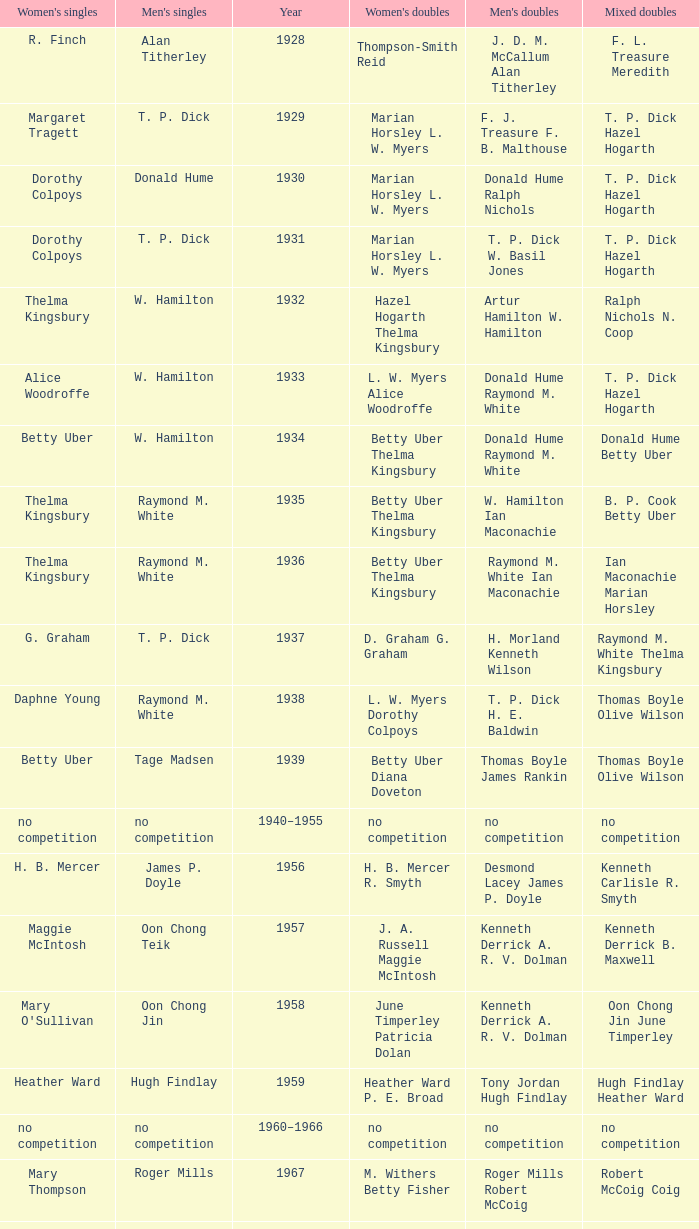Who won the Women's singles, in the year that Raymond M. White won the Men's singles and that W. Hamilton Ian Maconachie won the Men's doubles? Thelma Kingsbury. Parse the full table. {'header': ["Women's singles", "Men's singles", 'Year', "Women's doubles", "Men's doubles", 'Mixed doubles'], 'rows': [['R. Finch', 'Alan Titherley', '1928', 'Thompson-Smith Reid', 'J. D. M. McCallum Alan Titherley', 'F. L. Treasure Meredith'], ['Margaret Tragett', 'T. P. Dick', '1929', 'Marian Horsley L. W. Myers', 'F. J. Treasure F. B. Malthouse', 'T. P. Dick Hazel Hogarth'], ['Dorothy Colpoys', 'Donald Hume', '1930', 'Marian Horsley L. W. Myers', 'Donald Hume Ralph Nichols', 'T. P. Dick Hazel Hogarth'], ['Dorothy Colpoys', 'T. P. Dick', '1931', 'Marian Horsley L. W. Myers', 'T. P. Dick W. Basil Jones', 'T. P. Dick Hazel Hogarth'], ['Thelma Kingsbury', 'W. Hamilton', '1932', 'Hazel Hogarth Thelma Kingsbury', 'Artur Hamilton W. Hamilton', 'Ralph Nichols N. Coop'], ['Alice Woodroffe', 'W. Hamilton', '1933', 'L. W. Myers Alice Woodroffe', 'Donald Hume Raymond M. White', 'T. P. Dick Hazel Hogarth'], ['Betty Uber', 'W. Hamilton', '1934', 'Betty Uber Thelma Kingsbury', 'Donald Hume Raymond M. White', 'Donald Hume Betty Uber'], ['Thelma Kingsbury', 'Raymond M. White', '1935', 'Betty Uber Thelma Kingsbury', 'W. Hamilton Ian Maconachie', 'B. P. Cook Betty Uber'], ['Thelma Kingsbury', 'Raymond M. White', '1936', 'Betty Uber Thelma Kingsbury', 'Raymond M. White Ian Maconachie', 'Ian Maconachie Marian Horsley'], ['G. Graham', 'T. P. Dick', '1937', 'D. Graham G. Graham', 'H. Morland Kenneth Wilson', 'Raymond M. White Thelma Kingsbury'], ['Daphne Young', 'Raymond M. White', '1938', 'L. W. Myers Dorothy Colpoys', 'T. P. Dick H. E. Baldwin', 'Thomas Boyle Olive Wilson'], ['Betty Uber', 'Tage Madsen', '1939', 'Betty Uber Diana Doveton', 'Thomas Boyle James Rankin', 'Thomas Boyle Olive Wilson'], ['no competition', 'no competition', '1940–1955', 'no competition', 'no competition', 'no competition'], ['H. B. Mercer', 'James P. Doyle', '1956', 'H. B. Mercer R. Smyth', 'Desmond Lacey James P. Doyle', 'Kenneth Carlisle R. Smyth'], ['Maggie McIntosh', 'Oon Chong Teik', '1957', 'J. A. Russell Maggie McIntosh', 'Kenneth Derrick A. R. V. Dolman', 'Kenneth Derrick B. Maxwell'], ["Mary O'Sullivan", 'Oon Chong Jin', '1958', 'June Timperley Patricia Dolan', 'Kenneth Derrick A. R. V. Dolman', 'Oon Chong Jin June Timperley'], ['Heather Ward', 'Hugh Findlay', '1959', 'Heather Ward P. E. Broad', 'Tony Jordan Hugh Findlay', 'Hugh Findlay Heather Ward'], ['no competition', 'no competition', '1960–1966', 'no competition', 'no competition', 'no competition'], ['Mary Thompson', 'Roger Mills', '1967', 'M. Withers Betty Fisher', 'Roger Mills Robert McCoig', 'Robert McCoig Coig'], ['Julie Charles', 'Roger Mills', '1968', 'Julie Charles Angela Dickson', 'Roger Mills J. G. Pearson', 'Roger Mills Julie Charles'], ['Angela Dickson', 'Howard Jennings', '1969', 'J. Masters R. Gerrish', 'Mike Tredgett A. Finch', 'Howard Jennings Angela Dickson'], ['Angela Dickson', 'Howard Jennings', '1970', 'Angela Dickson Betty Fisher', 'Howard Jennings A. Fisher', 'Howard Jennings Angela Dickson'], ['no competition', 'no competition', '1971', 'no competition', 'no competition', 'no competition'], ['Betty Fisher', 'Mike Tredgett', '1972', 'Angela Dickson Betty Fisher', 'P. Smith William Kidd', 'Mike Tredgett Kathleen Whiting'], ['Barbara Beckett', 'John Gardner', '1973', 'Anne Forrest Kathleen Whiting', 'John McCloy Peter Moore', 'Clifford McIlwaine Barbara Beckett'], ['Barbara Beckett', 'Michael Wilkes', '1974', 'Barbara Beckett Sue Alfieri', 'Michael Wilkes Alan Connor', 'Michael Wilkes Anne Forrest'], ['Anne Statt', 'Michael Wilkes', '1975', 'Anne Statt Margo Winter', 'Michael Wilkes Alan Connor', 'Alan Connor Margo Winter'], ['Pat Davies', 'Kevin Jolly', '1976', 'Angela Dickson Sue Brimble', 'Tim Stokes Kevin Jolly', 'Howard Jennings Angela Dickson'], ['Paula Kilvington', 'David Eddy', '1977', 'Anne Statt Jane Webster', 'David Eddy Eddy Sutton', 'David Eddy Barbara Giles'], ['Gillian Gilks', 'Mike Tredgett', '1978', 'Barbara Sutton Marjan Ridder', 'David Eddy Eddy Sutton', 'Elliot Stuart Gillian Gilks'], ['Nora Perry', 'Kevin Jolly', '1979', 'Barbara Sutton Nora Perry', 'Ray Stevens Mike Tredgett', 'Mike Tredgett Nora Perry'], ['Jane Webster', 'Thomas Kihlström', '1980', 'Jane Webster Karen Puttick', 'Thomas Kihlström Bengt Fröman', 'Billy Gilliland Karen Puttick'], ['Gillian Gilks', 'Ray Stevens', '1981', 'Gillian Gilks Paula Kilvington', 'Ray Stevens Mike Tredgett', 'Mike Tredgett Nora Perry'], ['Karen Bridge', 'Steve Baddeley', '1982', 'Karen Chapman Sally Podger', 'David Eddy Eddy Sutton', 'Billy Gilliland Karen Chapman'], ['Sally Podger', 'Steve Butler', '1983', 'Nora Perry Jane Webster', 'Mike Tredgett Dipak Tailor', 'Dipak Tailor Nora Perry'], ['Karen Beckman', 'Steve Butler', '1984', 'Helen Troke Karen Chapman', 'Mike Tredgett Martin Dew', 'Mike Tredgett Karen Chapman'], ['Charlotte Hattens', 'Morten Frost', '1985', 'Gillian Gilks Helen Troke', 'Billy Gilliland Dan Travers', 'Martin Dew Gillian Gilks'], ['Fiona Elliott', 'Darren Hall', '1986', 'Karen Beckman Sara Halsall', 'Martin Dew Dipak Tailor', 'Jesper Knudsen Nettie Nielsen'], ['Fiona Elliott', 'Darren Hall', '1987', 'Karen Beckman Sara Halsall', 'Martin Dew Darren Hall', 'Martin Dew Gillian Gilks'], ['Lee Jung-mi', 'Vimal Kumar', '1988', 'Fiona Elliott Sara Halsall', 'Richard Outterside Mike Brown', 'Martin Dew Gillian Gilks'], ['Bang Soo-hyun', 'Darren Hall', '1989', 'Karen Beckman Sara Sankey', 'Nick Ponting Dave Wright', 'Mike Brown Jillian Wallwork'], ['Joanne Muggeridge', 'Mathew Smith', '1990', 'Karen Chapman Sara Sankey', 'Nick Ponting Dave Wright', 'Dave Wright Claire Palmer'], ['Denyse Julien', 'Vimal Kumar', '1991', 'Cheryl Johnson Julie Bradbury', 'Nick Ponting Dave Wright', 'Nick Ponting Joanne Wright'], ['Fiona Smith', 'Wei Yan', '1992', 'Denyse Julien Doris Piché', 'Michael Adams Chris Rees', 'Andy Goode Joanne Wright'], ['Sue Louis Lane', 'Anders Nielsen', '1993', 'Julie Bradbury Sara Sankey', 'Nick Ponting Dave Wright', 'Nick Ponting Joanne Wright'], ['Marina Andrievskaya', 'Darren Hall', '1994', 'Julie Bradbury Joanne Wright', 'Michael Adams Simon Archer', 'Chris Hunt Joanne Wright'], ['Denyse Julien', 'Peter Rasmussen', '1995', 'Julie Bradbury Joanne Wright', 'Andrei Andropov Nikolai Zuyev', 'Nick Ponting Joanne Wright'], ['Elena Rybkina', 'Colin Haughton', '1996', 'Elena Rybkina Marina Yakusheva', 'Andrei Andropov Nikolai Zuyev', 'Nikolai Zuyev Marina Yakusheva'], ['Kelly Morgan', 'Chris Bruil', '1997', 'Nicole van Hooren Brenda Conijn', 'Ian Pearson James Anderson', 'Quinten van Dalm Nicole van Hooren'], ['Brenda Beenhakker', 'Dicky Palyama', '1998', 'Sara Sankey Ella Tripp', 'James Anderson Ian Sullivan', 'James Anderson Sara Sankey'], ['Marina Andrievskaya', 'Daniel Eriksson', '1999', 'Marina Andrievskaya Catrine Bengtsson', 'Joachim Tesche Jean-Philippe Goyette', 'Henrik Andersson Marina Andrievskaya'], ['Marina Yakusheva', 'Richard Vaughan', '2000', 'Irina Ruslyakova Marina Yakusheva', 'Joachim Andersson Peter Axelsson', 'Peter Jeffrey Joanne Davies'], ['Brenda Beenhakker', 'Irwansyah', '2001', 'Sara Sankey Ella Tripp', 'Vincent Laigle Svetoslav Stoyanov', 'Nikolai Zuyev Marina Yakusheva'], ['Karina de Wit', 'Irwansyah', '2002', 'Ella Tripp Joanne Wright', 'Nikolai Zuyev Stanislav Pukhov', 'Nikolai Zuyev Marina Yakusheva'], ['Ella Karachkova', 'Irwansyah', '2003', 'Ella Karachkova Anastasia Russkikh', 'Ashley Thilthorpe Kristian Roebuck', 'Alexandr Russkikh Anastasia Russkikh'], ['Petya Nedelcheva', 'Nathan Rice', '2004', 'Petya Nedelcheva Yuan Wemyss', 'Reuben Gordown Aji Basuki Sindoro', 'Matthew Hughes Kelly Morgan'], ['Eleanor Cox', 'Chetan Anand', '2005', 'Hayley Connor Heather Olver', 'Andrew Ellis Dean George', 'Valiyaveetil Diju Jwala Gutta'], ['Huang Chia-chi', 'Irwansyah', '2006', 'Natalie Munt Mariana Agathangelou', 'Matthew Hughes Martyn Lewis', 'Kristian Roebuck Natalie Munt'], ['Jill Pittard', 'Marc Zwiebler', '2007', 'Chloe Magee Bing Huang', 'Wojciech Szkudlarczyk Adam Cwalina', 'Wojciech Szkudlarczyk Malgorzata Kurdelska'], ['Kati Tolmoff', 'Brice Leverdez', '2008', 'Mariana Agathangelou Jillie Cooper', 'Andrew Bowman Martyn Lewis', 'Watson Briggs Jillie Cooper'], ['Tatjana Bibik', 'Kristian Nielsen', '2009', 'Valeria Sorokina Nina Vislova', 'Vitaliy Durkin Alexandr Nikolaenko', 'Vitaliy Durkin Nina Vislova'], ['Anita Raj Kaur', 'Pablo Abián', '2010', 'Joanne Quay Swee Ling Anita Raj Kaur', 'Peter Käsbauer Josche Zurwonne', 'Peter Käsbauer Johanna Goliszewski'], ['Nicole Schaller', 'Niluka Karunaratne', '2011', 'Ng Hui Ern Ng Hui Lin', 'Chris Coles Matthew Nottingham', 'Martin Campbell Ng Hui Lin'], ['Chiang Mei-hui', 'Chou Tien-chen', '2012', 'Gabrielle White Lauren Smith', 'Marcus Ellis Paul Van Rietvelde', 'Marcus Ellis Gabrielle White']]} 